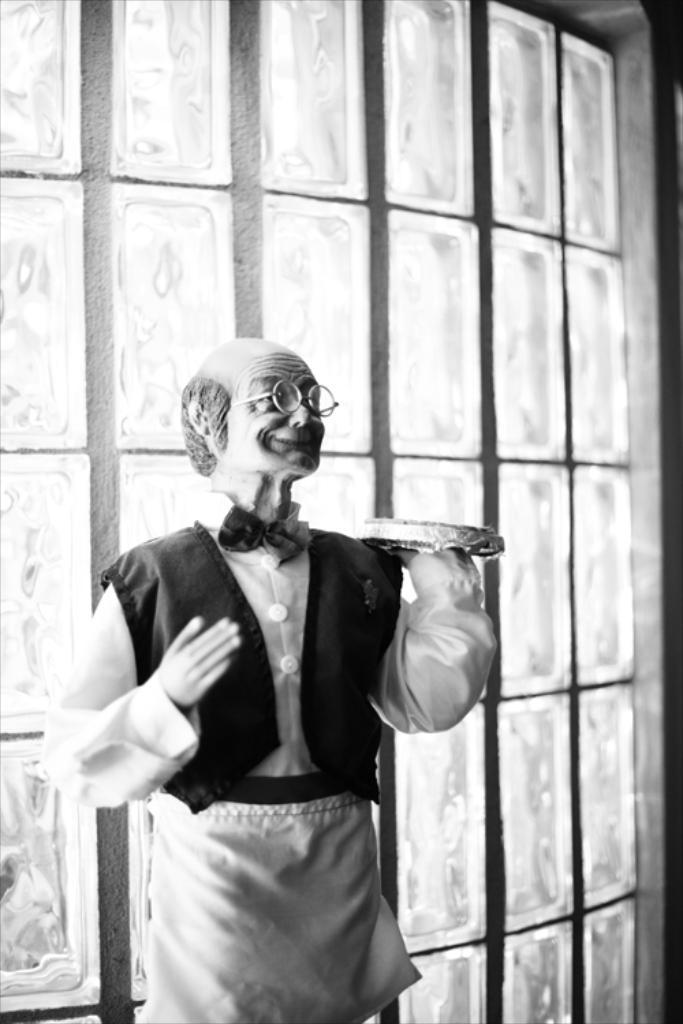What is the main subject in the center of the image? There is a statue of a man in the center of the image. What can be seen in the background of the image? There is a wall in the background of the image. What type of crack is visible on the statue in the image? There is no crack visible on the statue in the image. What flag is being waved by the statue in the image? The statue does not have a flag, nor is it depicted as waving one. 